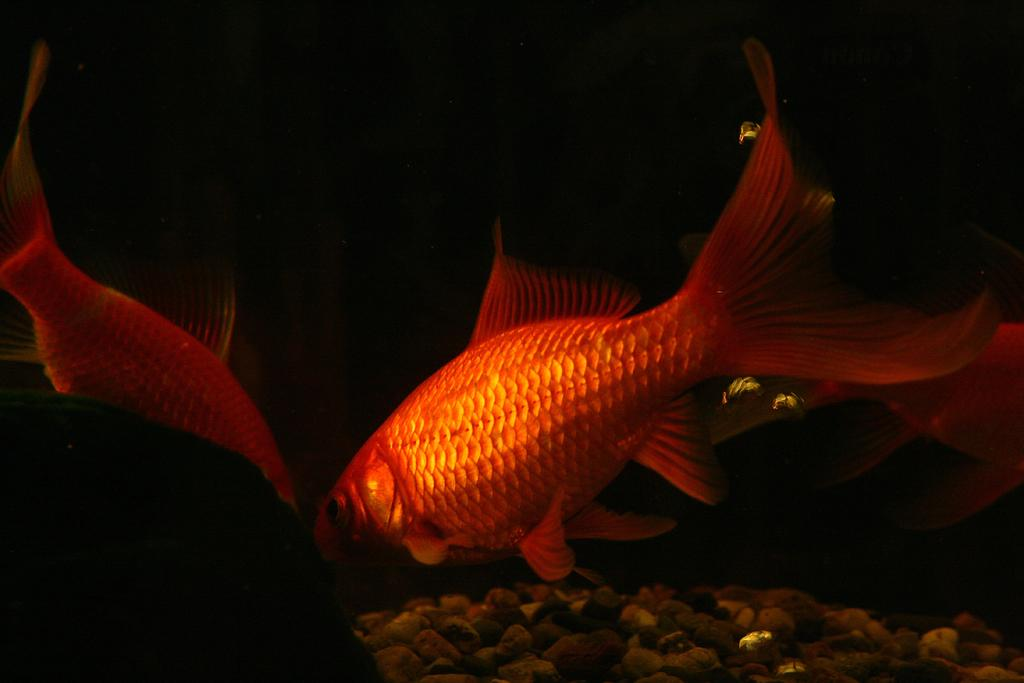What type of animals can be seen in the image? There are fishes in the image. What other objects are present in the image besides the fishes? There are rocks in the image. Can you describe the background of the image? The background of the image is dark. What type of potato can be seen in the image? There is no potato present in the image. Is there a prison visible in the image? There is no prison present in the image. 